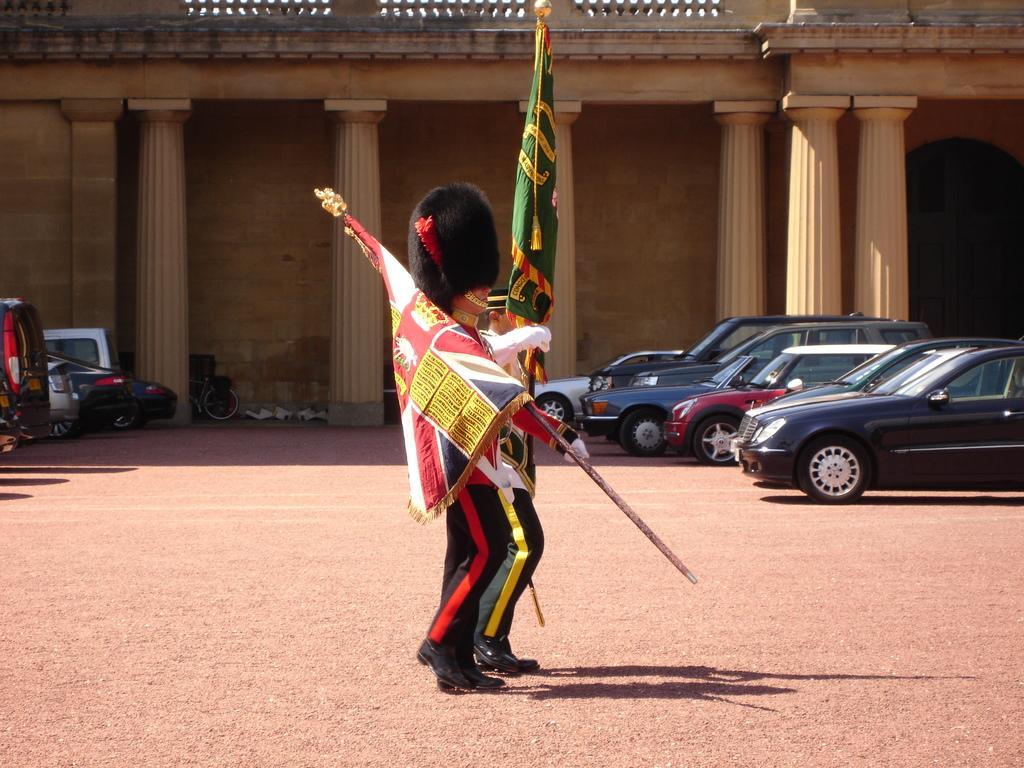Can you describe this image briefly? In this image in the center there are two people who are holding pole and flags, and on the right side and left side there are vehicles. In the background there are pillars and building and some objects, at the bottom there is a walkway. 